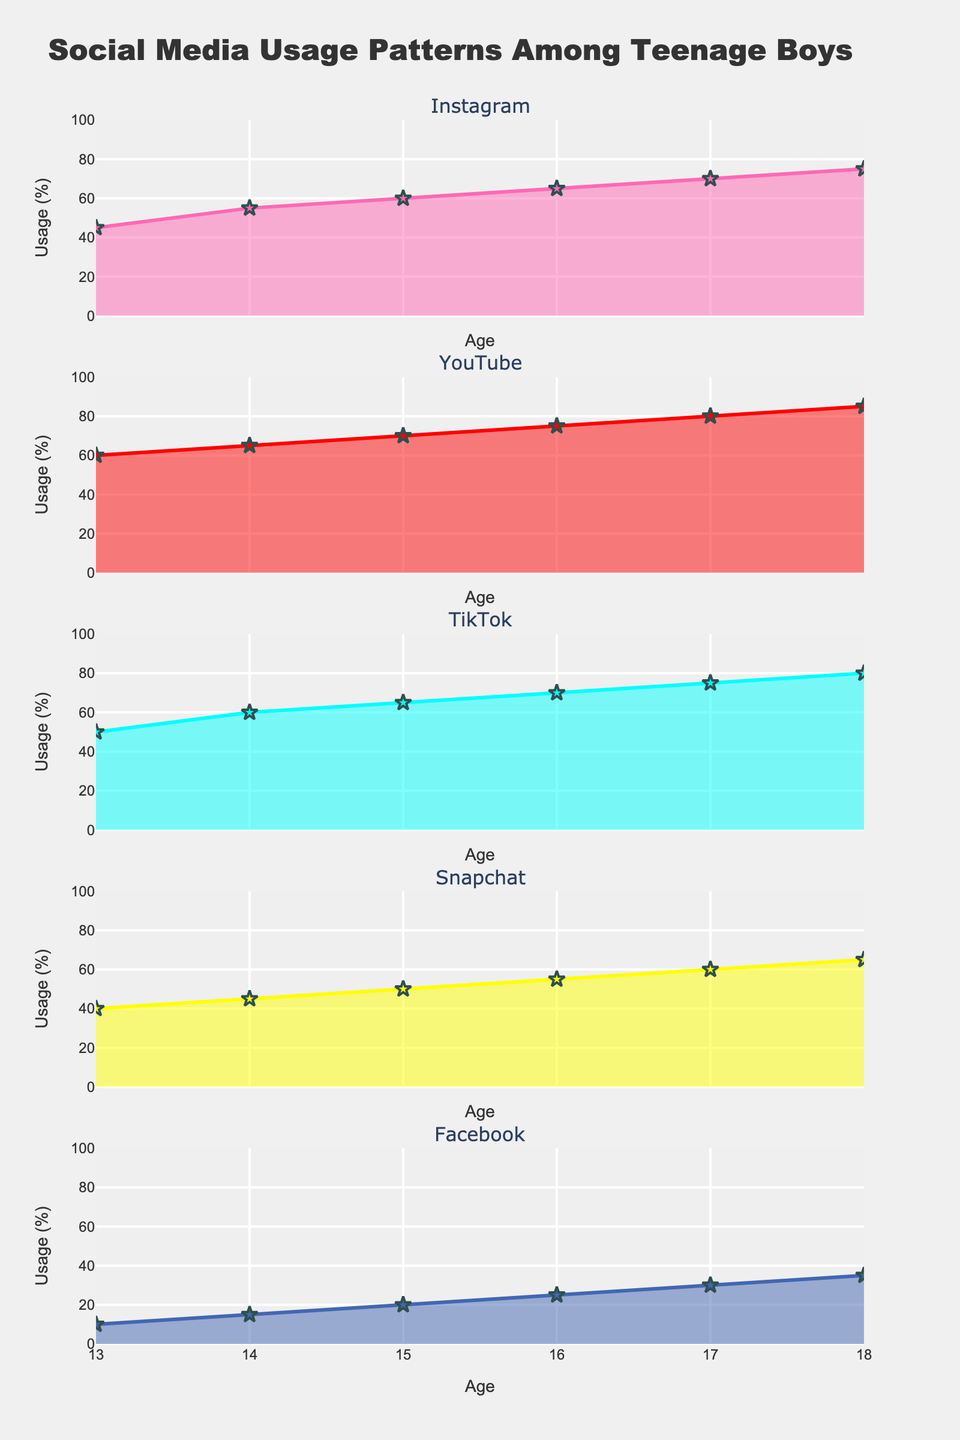What is the title of the figure? The title is located at the top of the figure and reads "Social Media Usage Patterns Among Teenage Boys".
Answer: Social Media Usage Patterns Among Teenage Boys What are the social media platforms shown in the figure? The subplot titles indicate the platforms, which are Instagram, YouTube, TikTok, Snapchat, and Facebook.
Answer: Instagram, YouTube, TikTok, Snapchat, Facebook Which social media platform has the highest usage among 18-year-old boys? Referring to the data points for age 18 on the respective subplots, YouTube has the highest usage at 85%.
Answer: YouTube At age 15, how does TikTok usage compare to Facebook usage? Checking the data points for age 15 on the respective subplots, TikTok usage is 65%, while Facebook usage is 20%. Thus, TikTok usage is higher.
Answer: TikTok usage is higher What is the trend observed in Snapchat usage from age 13 to 18? Looking at the Snapchat subplot, the usage percentage increases consistently from 40% at age 13 to 65% at age 18.
Answer: Increasing trend What is the total combined usage percentage across all platforms for 17-year-old boys? Adding up the usage percentages for age 17: Instagram (70) + YouTube (80) + TikTok (75) + Snapchat (60) + Facebook (30) = 315%.
Answer: 315% Which age group shows the least usage of Facebook? From the Facebook subplot, the usage percentages can be compared across ages. The least usage, 10%, is observed at age 13.
Answer: Age 13 Between ages 14 and 16, which platform shows the most significant increase in usage? Calculate the differences for each platform:
- Instagram: 65 (16) - 55 (14) = 10
- YouTube: 75 (16) - 65 (14) = 10
- TikTok: 70 (16) - 60 (14) = 10
- Snapchat: 55 (16) - 45 (14) = 10
- Facebook: 25 (16) - 15 (14) = 10
All platforms increase usage by 10%, thus none show a significantly larger increase.
Answer: None, all increase by 10% What is the average usage percentage of Instagram from ages 13 to 18? Sum the usage percentages for Instagram across all ages and divide by the number of ages: (45 + 55 + 60 + 65 + 70 + 75) / 6 = 61.67%.
Answer: 61.67% How does the overall trend for Facebook usage differ from that of TikTok? By observing the subplots: Facebook usage starts low and increases gradually, while TikTok usage starts higher and increases at a faster rate.
Answer: Facebook increases gradually; TikTok increases faster 